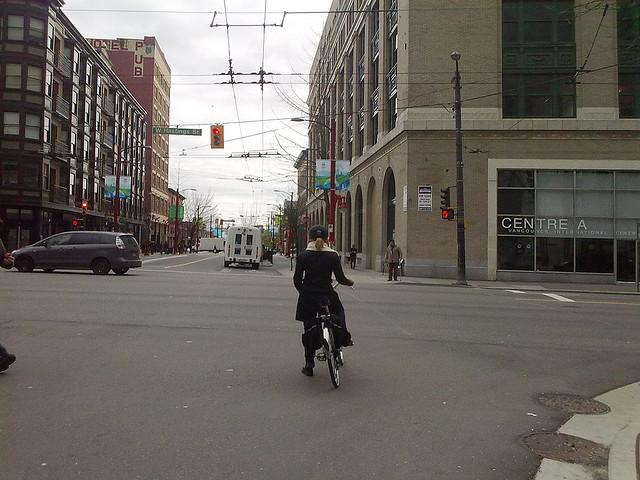What province is she riding in? british columbia 